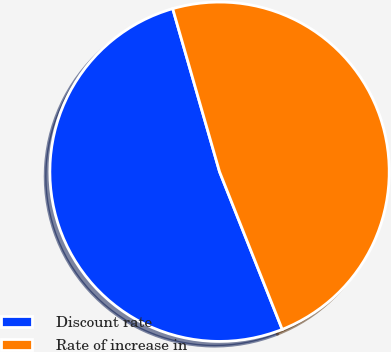Convert chart. <chart><loc_0><loc_0><loc_500><loc_500><pie_chart><fcel>Discount rate<fcel>Rate of increase in<nl><fcel>51.57%<fcel>48.43%<nl></chart> 